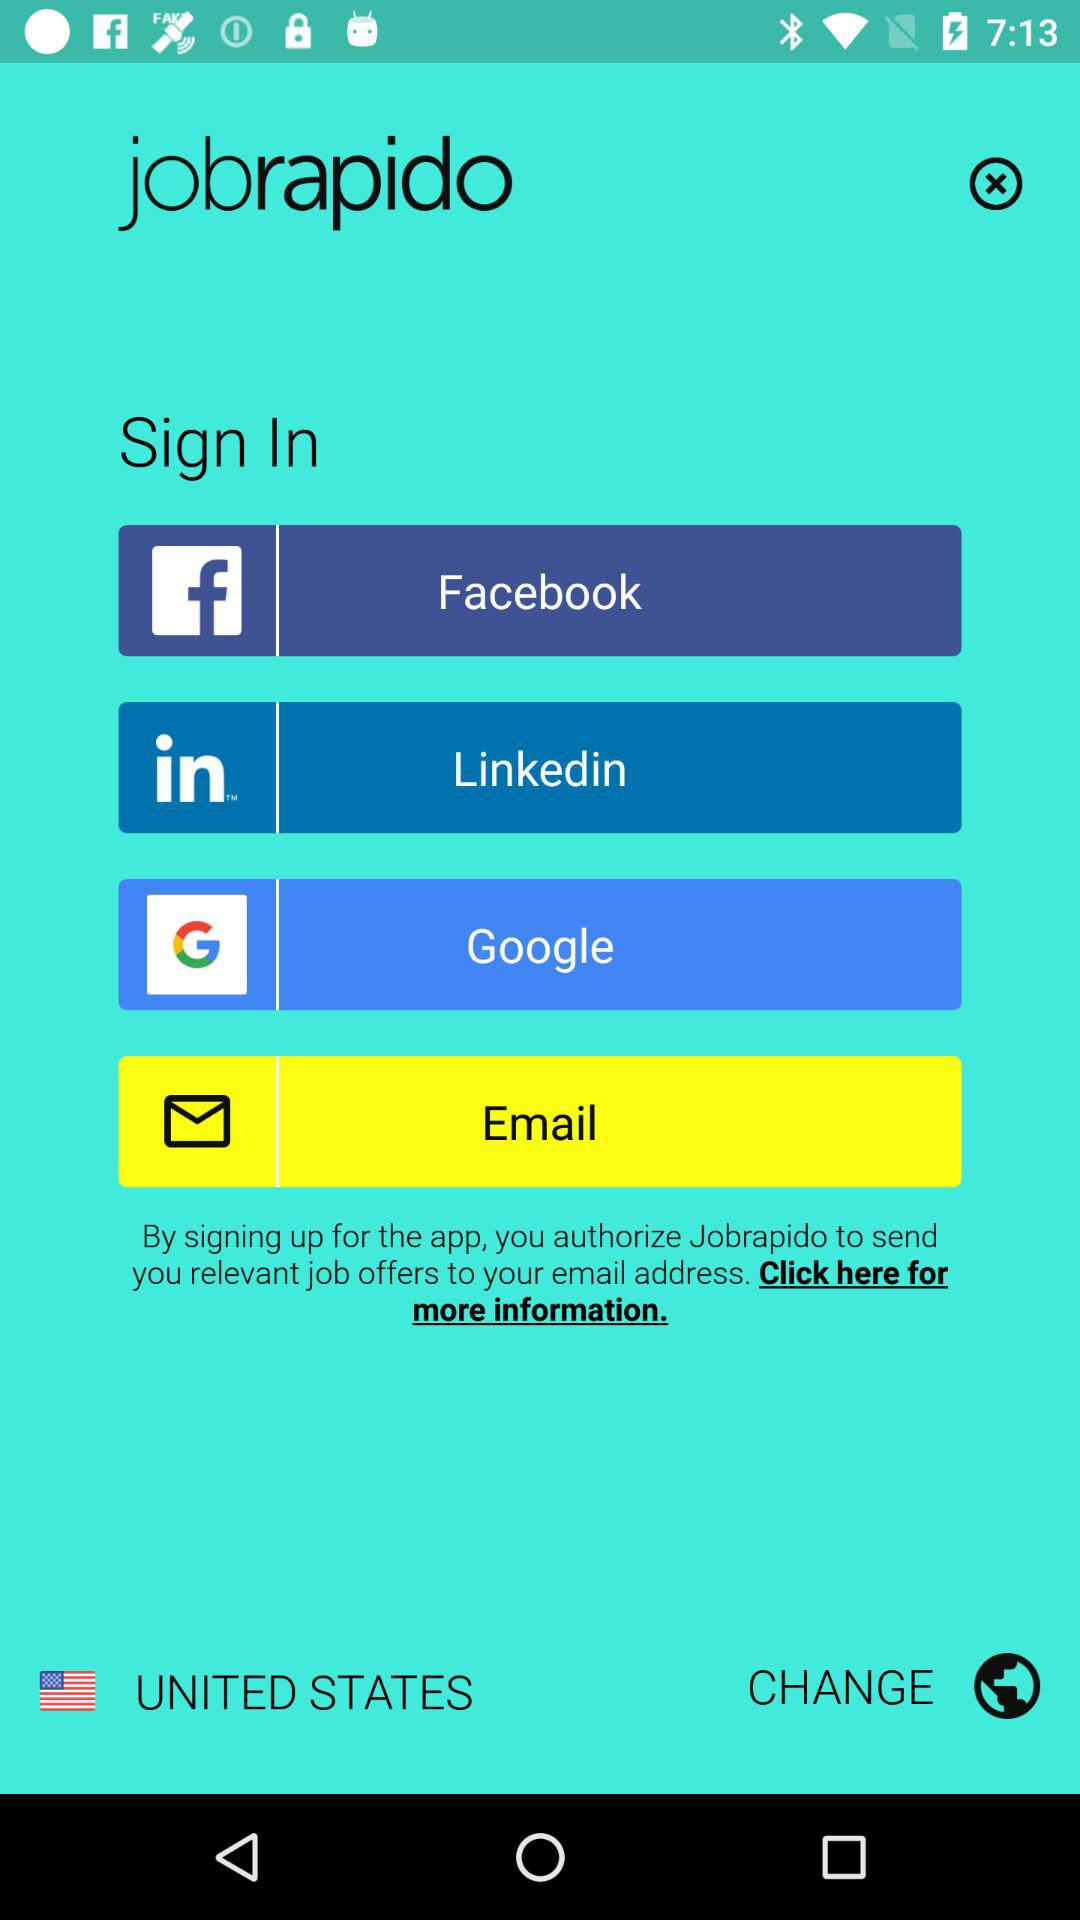How many sign in methods are offered?
Answer the question using a single word or phrase. 4 